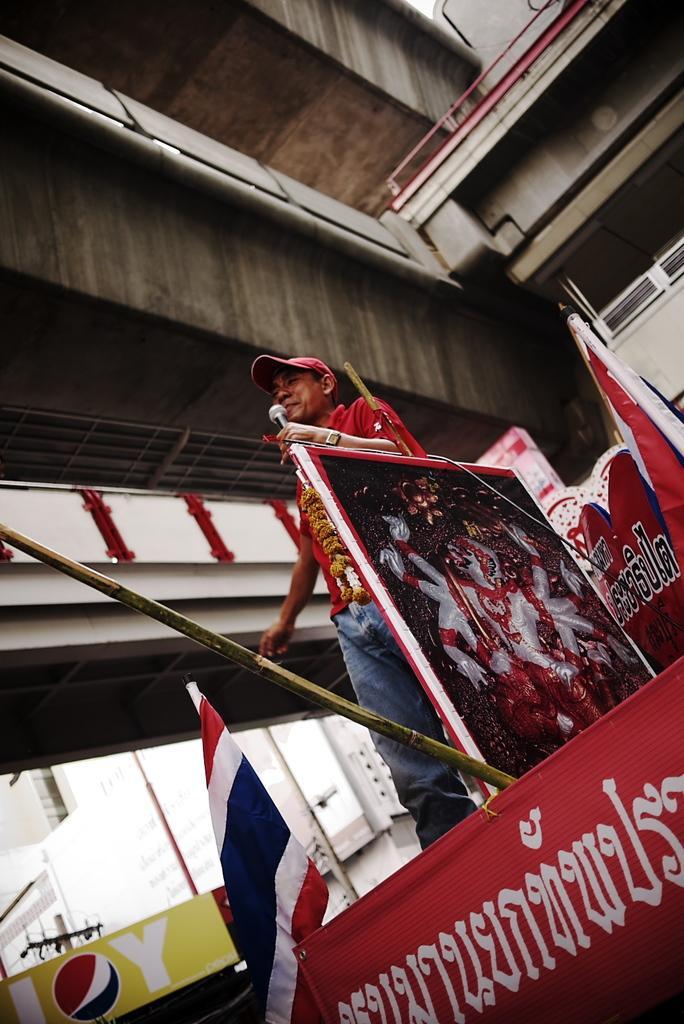Please provide a concise description of this image. In this image we can see a person standing and holding a microphone. And we can see the posters and flags. And we can see the bridge and buildings. 